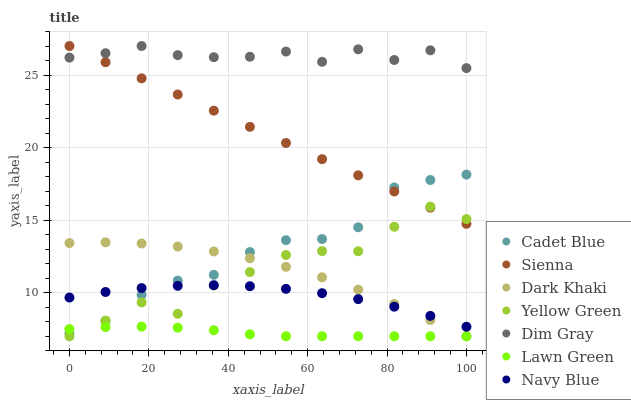Does Lawn Green have the minimum area under the curve?
Answer yes or no. Yes. Does Dim Gray have the maximum area under the curve?
Answer yes or no. Yes. Does Yellow Green have the minimum area under the curve?
Answer yes or no. No. Does Yellow Green have the maximum area under the curve?
Answer yes or no. No. Is Sienna the smoothest?
Answer yes or no. Yes. Is Yellow Green the roughest?
Answer yes or no. Yes. Is Dim Gray the smoothest?
Answer yes or no. No. Is Dim Gray the roughest?
Answer yes or no. No. Does Dark Khaki have the lowest value?
Answer yes or no. Yes. Does Dim Gray have the lowest value?
Answer yes or no. No. Does Sienna have the highest value?
Answer yes or no. Yes. Does Yellow Green have the highest value?
Answer yes or no. No. Is Lawn Green less than Dim Gray?
Answer yes or no. Yes. Is Dim Gray greater than Yellow Green?
Answer yes or no. Yes. Does Navy Blue intersect Yellow Green?
Answer yes or no. Yes. Is Navy Blue less than Yellow Green?
Answer yes or no. No. Is Navy Blue greater than Yellow Green?
Answer yes or no. No. Does Lawn Green intersect Dim Gray?
Answer yes or no. No. 